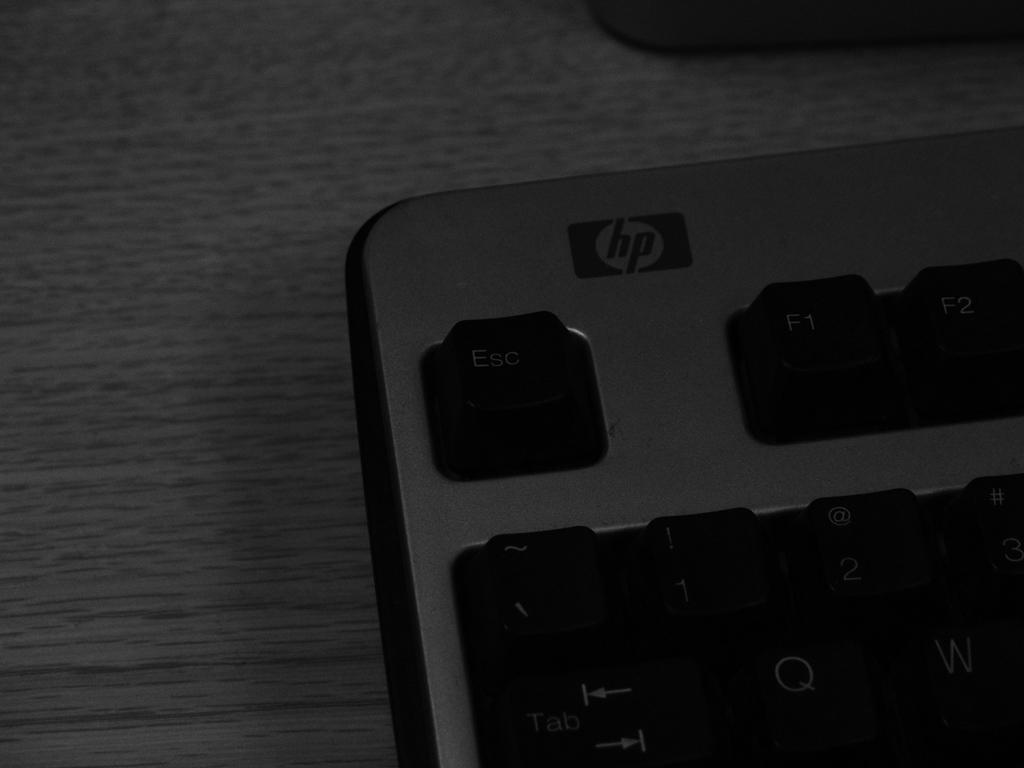Provide a one-sentence caption for the provided image. A partial view of the Esc, F1, and F2 keys on a hp keyboard. 